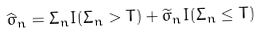Convert formula to latex. <formula><loc_0><loc_0><loc_500><loc_500>\widehat { \sigma } _ { n } = \Sigma _ { n } { I } ( \Sigma _ { n } > T ) + \widetilde { \sigma } _ { n } { I } ( \Sigma _ { n } \leq T )</formula> 